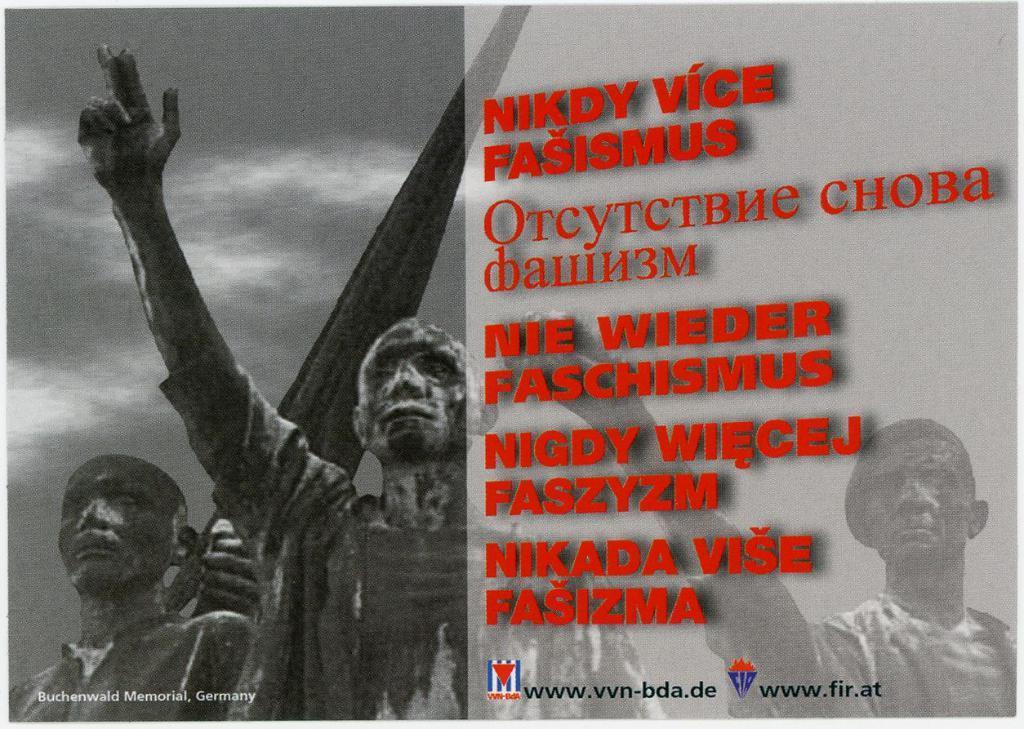How would you summarize this image in a sentence or two? This is an animated image. On the bottom left, there is a watermark. On the left side, there are two statues. On the right side, there are red color texts and two watermarks on a surface. In the background, there is a statue, there is a tower and there are clouds in the sky. 